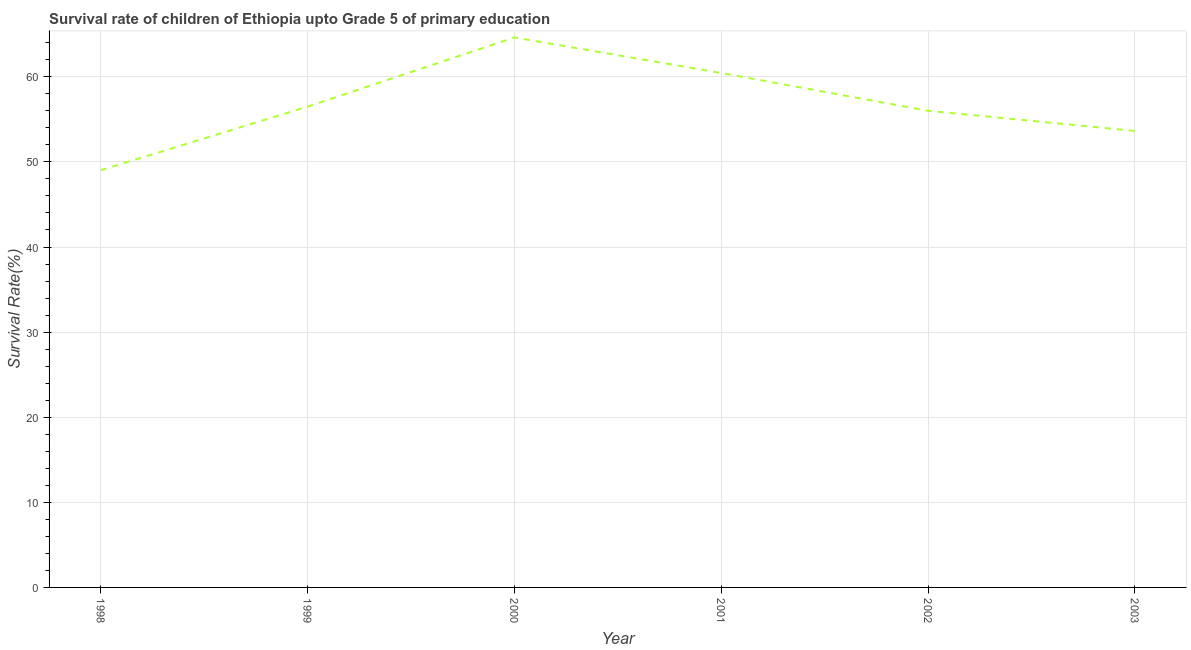What is the survival rate in 1999?
Your answer should be compact. 56.5. Across all years, what is the maximum survival rate?
Your response must be concise. 64.62. Across all years, what is the minimum survival rate?
Offer a terse response. 49.03. In which year was the survival rate maximum?
Ensure brevity in your answer.  2000. What is the sum of the survival rate?
Make the answer very short. 340.24. What is the difference between the survival rate in 1998 and 2001?
Offer a very short reply. -11.42. What is the average survival rate per year?
Your answer should be very brief. 56.71. What is the median survival rate?
Offer a terse response. 56.25. In how many years, is the survival rate greater than 2 %?
Your answer should be compact. 6. Do a majority of the years between 2003 and 2000 (inclusive) have survival rate greater than 52 %?
Offer a terse response. Yes. What is the ratio of the survival rate in 2000 to that in 2001?
Your answer should be very brief. 1.07. Is the survival rate in 2000 less than that in 2002?
Provide a short and direct response. No. Is the difference between the survival rate in 2000 and 2002 greater than the difference between any two years?
Your response must be concise. No. What is the difference between the highest and the second highest survival rate?
Your response must be concise. 4.18. What is the difference between the highest and the lowest survival rate?
Your answer should be very brief. 15.6. Does the survival rate monotonically increase over the years?
Provide a short and direct response. No. How many lines are there?
Provide a short and direct response. 1. How many years are there in the graph?
Offer a terse response. 6. What is the difference between two consecutive major ticks on the Y-axis?
Give a very brief answer. 10. Does the graph contain any zero values?
Your answer should be compact. No. Does the graph contain grids?
Offer a very short reply. Yes. What is the title of the graph?
Provide a succinct answer. Survival rate of children of Ethiopia upto Grade 5 of primary education. What is the label or title of the Y-axis?
Provide a succinct answer. Survival Rate(%). What is the Survival Rate(%) in 1998?
Your answer should be compact. 49.03. What is the Survival Rate(%) in 1999?
Make the answer very short. 56.5. What is the Survival Rate(%) of 2000?
Give a very brief answer. 64.62. What is the Survival Rate(%) of 2001?
Offer a terse response. 60.44. What is the Survival Rate(%) of 2002?
Keep it short and to the point. 56.01. What is the Survival Rate(%) of 2003?
Offer a terse response. 53.64. What is the difference between the Survival Rate(%) in 1998 and 1999?
Offer a terse response. -7.47. What is the difference between the Survival Rate(%) in 1998 and 2000?
Provide a short and direct response. -15.6. What is the difference between the Survival Rate(%) in 1998 and 2001?
Provide a succinct answer. -11.42. What is the difference between the Survival Rate(%) in 1998 and 2002?
Offer a terse response. -6.98. What is the difference between the Survival Rate(%) in 1998 and 2003?
Offer a very short reply. -4.61. What is the difference between the Survival Rate(%) in 1999 and 2000?
Ensure brevity in your answer.  -8.13. What is the difference between the Survival Rate(%) in 1999 and 2001?
Your answer should be compact. -3.95. What is the difference between the Survival Rate(%) in 1999 and 2002?
Offer a terse response. 0.49. What is the difference between the Survival Rate(%) in 1999 and 2003?
Provide a succinct answer. 2.86. What is the difference between the Survival Rate(%) in 2000 and 2001?
Your answer should be very brief. 4.18. What is the difference between the Survival Rate(%) in 2000 and 2002?
Your response must be concise. 8.61. What is the difference between the Survival Rate(%) in 2000 and 2003?
Offer a terse response. 10.98. What is the difference between the Survival Rate(%) in 2001 and 2002?
Your response must be concise. 4.44. What is the difference between the Survival Rate(%) in 2001 and 2003?
Make the answer very short. 6.8. What is the difference between the Survival Rate(%) in 2002 and 2003?
Offer a terse response. 2.37. What is the ratio of the Survival Rate(%) in 1998 to that in 1999?
Provide a short and direct response. 0.87. What is the ratio of the Survival Rate(%) in 1998 to that in 2000?
Give a very brief answer. 0.76. What is the ratio of the Survival Rate(%) in 1998 to that in 2001?
Your answer should be very brief. 0.81. What is the ratio of the Survival Rate(%) in 1998 to that in 2002?
Keep it short and to the point. 0.88. What is the ratio of the Survival Rate(%) in 1998 to that in 2003?
Provide a short and direct response. 0.91. What is the ratio of the Survival Rate(%) in 1999 to that in 2000?
Ensure brevity in your answer.  0.87. What is the ratio of the Survival Rate(%) in 1999 to that in 2001?
Your answer should be compact. 0.94. What is the ratio of the Survival Rate(%) in 1999 to that in 2002?
Offer a very short reply. 1.01. What is the ratio of the Survival Rate(%) in 1999 to that in 2003?
Provide a succinct answer. 1.05. What is the ratio of the Survival Rate(%) in 2000 to that in 2001?
Give a very brief answer. 1.07. What is the ratio of the Survival Rate(%) in 2000 to that in 2002?
Make the answer very short. 1.15. What is the ratio of the Survival Rate(%) in 2000 to that in 2003?
Your answer should be compact. 1.21. What is the ratio of the Survival Rate(%) in 2001 to that in 2002?
Your answer should be very brief. 1.08. What is the ratio of the Survival Rate(%) in 2001 to that in 2003?
Provide a short and direct response. 1.13. What is the ratio of the Survival Rate(%) in 2002 to that in 2003?
Ensure brevity in your answer.  1.04. 